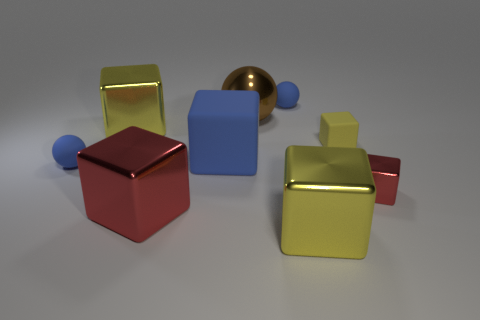How many other things are made of the same material as the large blue object?
Provide a short and direct response. 3. What is the size of the other red metal thing that is the same shape as the small red thing?
Offer a terse response. Large. Does the big yellow object that is in front of the large red metallic object have the same material as the big yellow cube that is on the left side of the large ball?
Offer a terse response. Yes. Are there fewer small matte balls to the left of the large blue object than tiny yellow matte blocks?
Keep it short and to the point. No. Are there any other things that have the same shape as the tiny metal thing?
Ensure brevity in your answer.  Yes. What is the color of the large rubber object that is the same shape as the small metallic thing?
Keep it short and to the point. Blue. There is a red thing on the left side of the brown ball; is its size the same as the big brown metallic sphere?
Make the answer very short. Yes. There is a yellow shiny block that is on the left side of the yellow thing that is in front of the blue matte block; what is its size?
Your response must be concise. Large. Do the brown ball and the tiny ball right of the large blue rubber thing have the same material?
Your response must be concise. No. Are there fewer large rubber cubes that are to the right of the small red metal object than small blue rubber balls that are behind the metal sphere?
Ensure brevity in your answer.  Yes. 